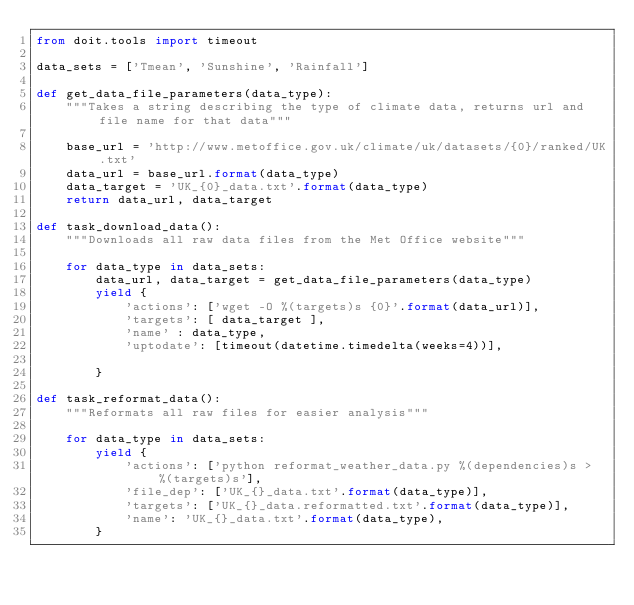Convert code to text. <code><loc_0><loc_0><loc_500><loc_500><_Python_>from doit.tools import timeout 

data_sets = ['Tmean', 'Sunshine', 'Rainfall']

def get_data_file_parameters(data_type):
    """Takes a string describing the type of climate data, returns url and file name for that data"""

    base_url = 'http://www.metoffice.gov.uk/climate/uk/datasets/{0}/ranked/UK.txt'
    data_url = base_url.format(data_type)
    data_target = 'UK_{0}_data.txt'.format(data_type)
    return data_url, data_target

def task_download_data():
    """Downloads all raw data files from the Met Office website"""

    for data_type in data_sets:
        data_url, data_target = get_data_file_parameters(data_type)
        yield {
            'actions': ['wget -O %(targets)s {0}'.format(data_url)],
            'targets': [ data_target ],
            'name' : data_type,
            'uptodate': [timeout(datetime.timedelta(weeks=4))],

        }

def task_reformat_data():
    """Reformats all raw files for easier analysis"""

    for data_type in data_sets:
        yield {
            'actions': ['python reformat_weather_data.py %(dependencies)s > %(targets)s'],
            'file_dep': ['UK_{}_data.txt'.format(data_type)],
            'targets': ['UK_{}_data.reformatted.txt'.format(data_type)],
            'name': 'UK_{}_data.txt'.format(data_type),
        }</code> 